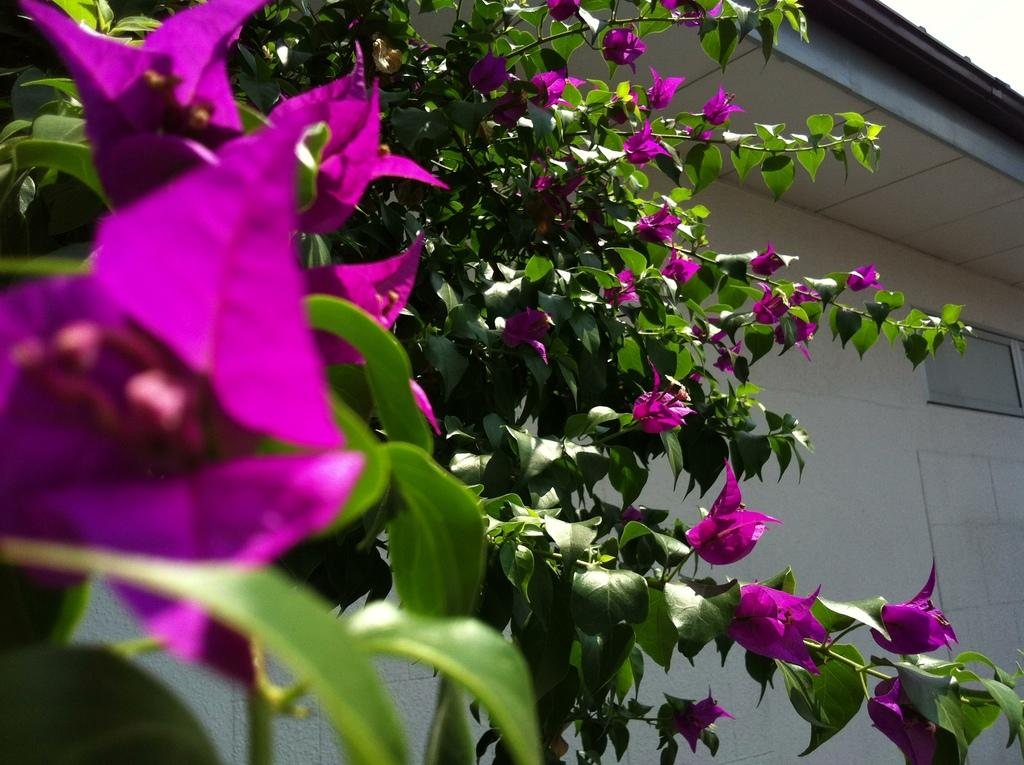What is located in the foreground of the image? There are flowers in the foreground of the image. How are the flowers connected to the tree? The flowers are attached to a tree. What can be seen in the background of the image? There is a wall of a building in the background of the image. What is visible at the top of the image? The sky is visible at the top of the image. How many units of loss can be seen in the image? There is no reference to any units of loss in the image; it features flowers, a tree, a building wall, and the sky. 